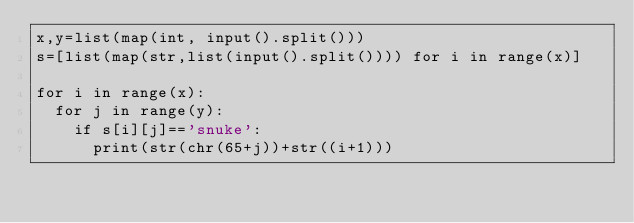Convert code to text. <code><loc_0><loc_0><loc_500><loc_500><_Python_>x,y=list(map(int, input().split()))
s=[list(map(str,list(input().split()))) for i in range(x)]

for i in range(x):
	for j in range(y):
		if s[i][j]=='snuke':
			print(str(chr(65+j))+str((i+1)))</code> 